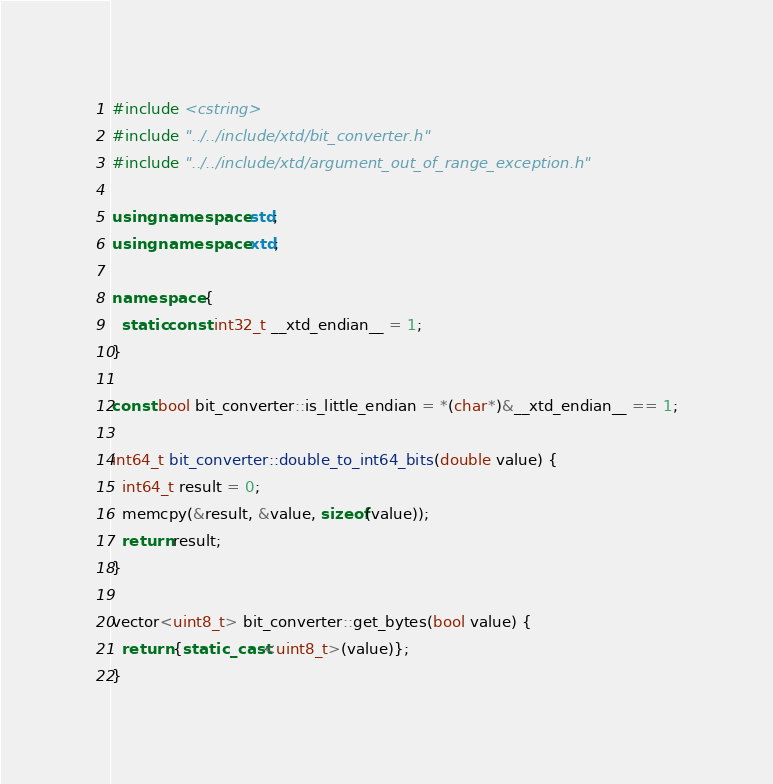<code> <loc_0><loc_0><loc_500><loc_500><_C++_>#include <cstring>
#include "../../include/xtd/bit_converter.h"
#include "../../include/xtd/argument_out_of_range_exception.h"

using namespace std;
using namespace xtd;

namespace {
  static const int32_t __xtd_endian__ = 1;
}

const bool bit_converter::is_little_endian = *(char*)&__xtd_endian__ == 1;

int64_t bit_converter::double_to_int64_bits(double value) {
  int64_t result = 0;
  memcpy(&result, &value, sizeof(value));
  return result;
}

vector<uint8_t> bit_converter::get_bytes(bool value) {
  return {static_cast<uint8_t>(value)};
}
</code> 